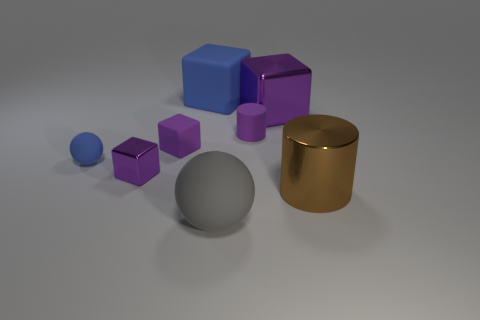How many things are the same color as the small matte cube? Including the small matte cube, there are four objects that share the same vibrant purple hue. This includes the small cube itself, another slightly larger cube, one small sphere, and a tall cylinder. These items stand out due to their identical coloring amidst an assortment of other colored geometrical shapes. 